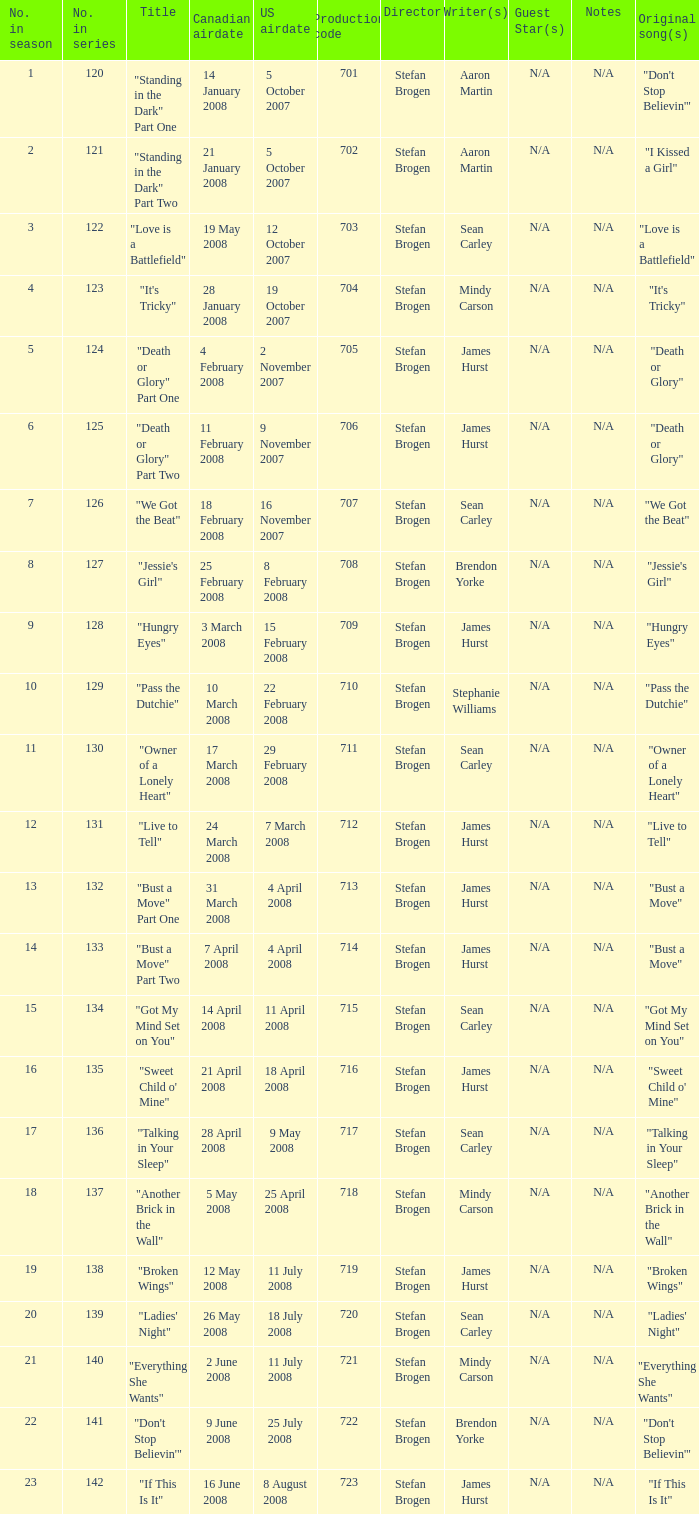The canadian airdate of 11 february 2008 applied to what series number? 1.0. 